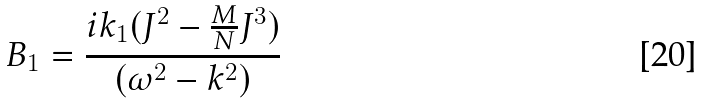<formula> <loc_0><loc_0><loc_500><loc_500>B _ { 1 } = \frac { i k _ { 1 } ( J ^ { 2 } - \frac { M } { N } J ^ { 3 } ) } { ( { \omega } ^ { 2 } - k ^ { 2 } ) }</formula> 